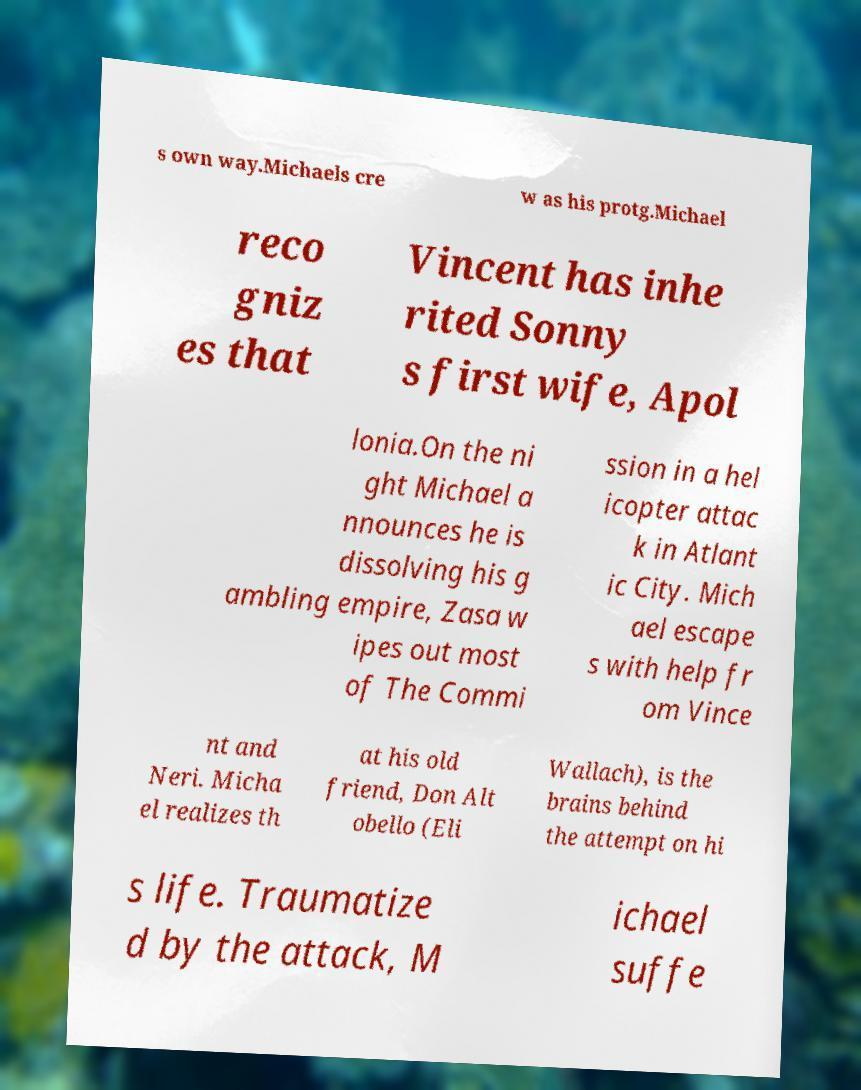Can you accurately transcribe the text from the provided image for me? s own way.Michaels cre w as his protg.Michael reco gniz es that Vincent has inhe rited Sonny s first wife, Apol lonia.On the ni ght Michael a nnounces he is dissolving his g ambling empire, Zasa w ipes out most of The Commi ssion in a hel icopter attac k in Atlant ic City. Mich ael escape s with help fr om Vince nt and Neri. Micha el realizes th at his old friend, Don Alt obello (Eli Wallach), is the brains behind the attempt on hi s life. Traumatize d by the attack, M ichael suffe 